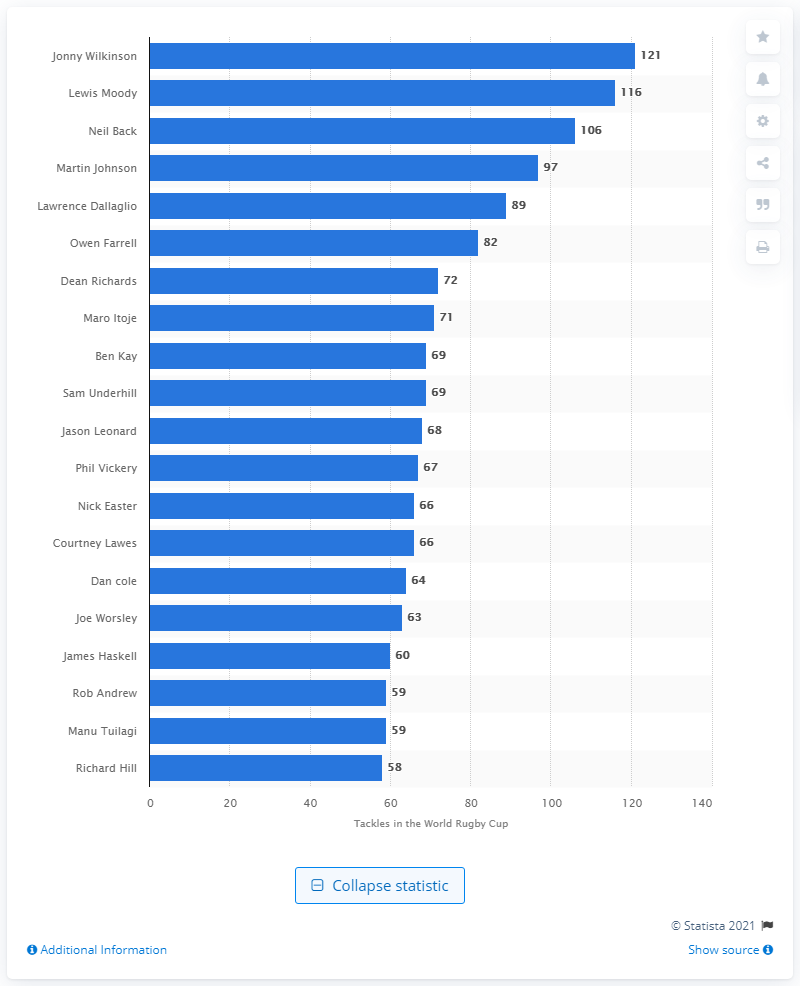Give some essential details in this illustration. I made 121 tackles at the RWC, Wilkinson! The record for the most tackles made at the Rugby World Cup belongs to Jonny Wilkinson. 